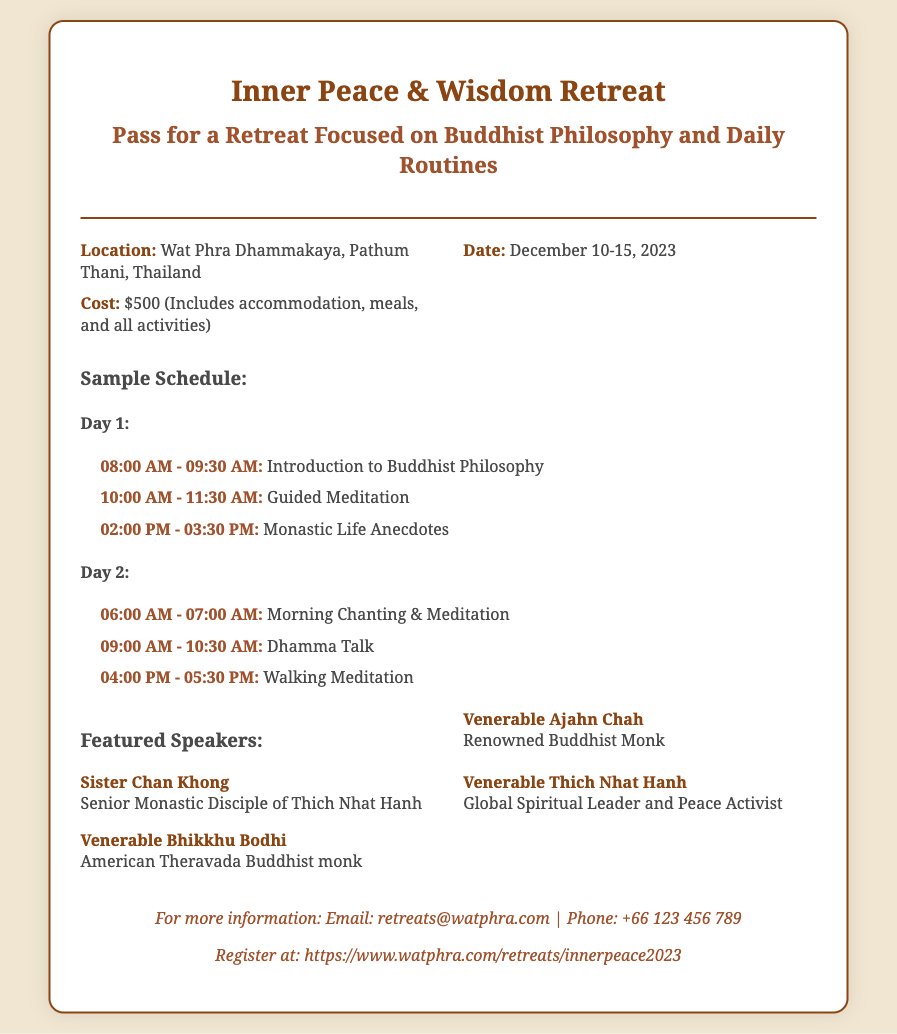What is the location of the retreat? The location is explicitly mentioned in the document, stating it is at Wat Phra Dhammakaya, Pathum Thani, Thailand.
Answer: Wat Phra Dhammakaya, Pathum Thani, Thailand What are the dates of the retreat? The specific dates of the retreat are provided in the document, which are December 10-15, 2023.
Answer: December 10-15, 2023 How much does the retreat cost? The cost of the retreat is clearly mentioned in the document as $500.
Answer: $500 What time does the introduction to Buddhist philosophy start on Day 1? The specific time for the introduction to Buddhist philosophy is given in the schedule section of Day 1, which is from 08:00 AM to 09:30 AM.
Answer: 08:00 AM - 09:30 AM Who is one of the featured speakers at the retreat? The document lists several featured speakers, and one can be chosen, such as Venerable Ajahn Chah.
Answer: Venerable Ajahn Chah What activity is scheduled for Day 2 at 04:00 PM? The document outlines a specific activity for Day 2, which is Walking Meditation at 04:00 PM.
Answer: Walking Meditation What type of food is included in the cost? The document states that meals are included in the cost of the retreat, although no specific food types are mentioned.
Answer: Meals How can someone register for the retreat? The document provides a registration link, hence the answer refers to that specific instruction.
Answer: https://www.watphra.com/retreats/innerpeace2023 What notable absence is there in the speaker list? By observing the speaker list, it's noticeable that no female speakers from the Theravada tradition appear.
Answer: None from Theravada tradition 